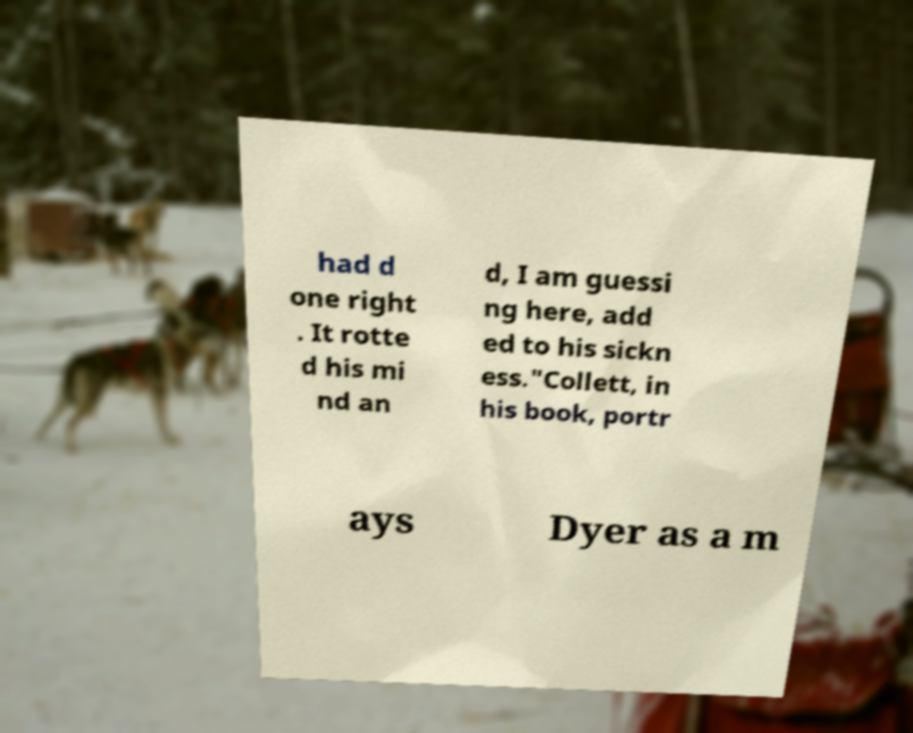I need the written content from this picture converted into text. Can you do that? had d one right . It rotte d his mi nd an d, I am guessi ng here, add ed to his sickn ess."Collett, in his book, portr ays Dyer as a m 